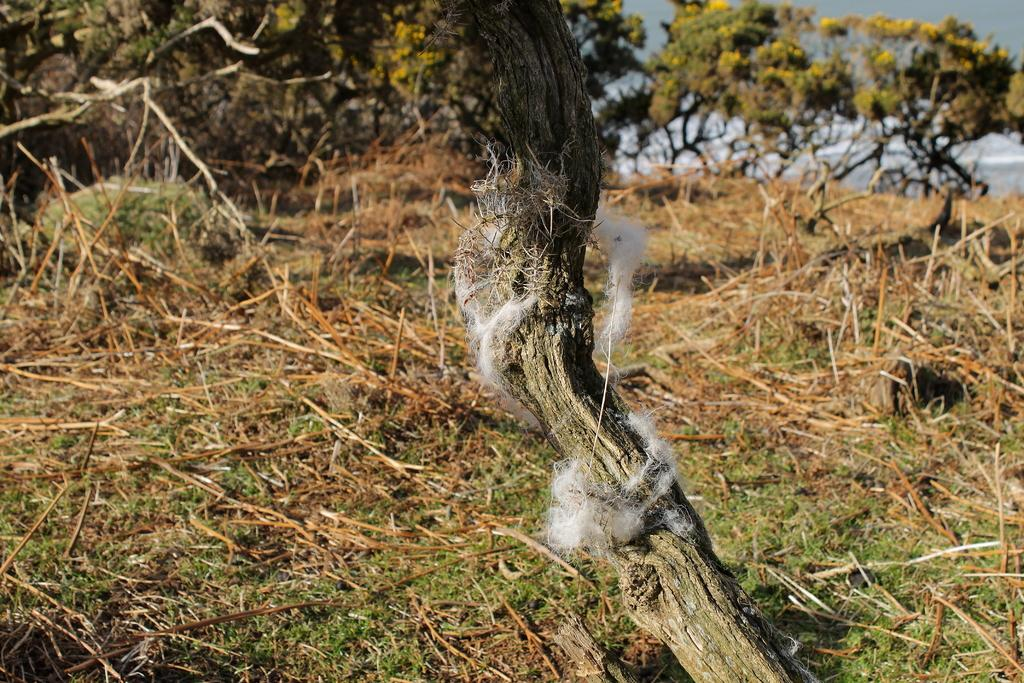What type of vegetation can be seen at the top of the image? There are trees visible at the top of the image. Can you describe any specific details about the trees? Cotton is present on a branch of a tree in the image. What invention can be seen being used by the chicken in the image? There is no chicken or invention present in the image. How does the quicksand affect the trees in the image? There is no quicksand present in the image, so it does not affect the trees. 